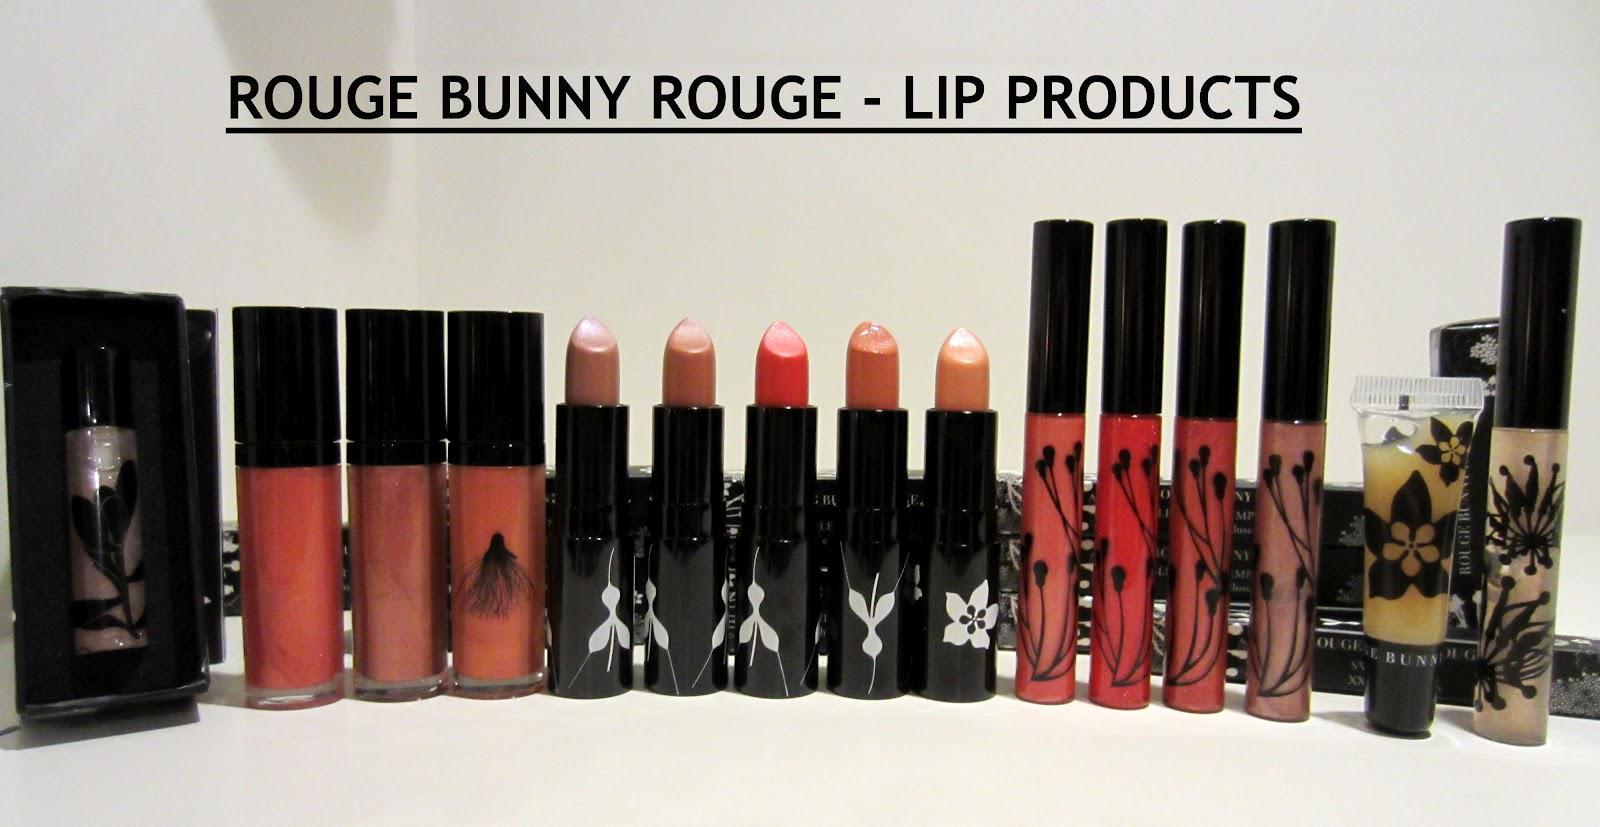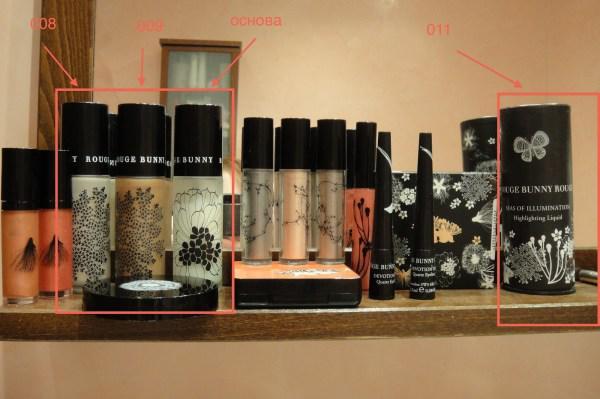The first image is the image on the left, the second image is the image on the right. For the images displayed, is the sentence "There are at least eight lip products in total." factually correct? Answer yes or no. Yes. The first image is the image on the left, the second image is the image on the right. Considering the images on both sides, is "there is no more then one lipstick visible in the right side pic" valid? Answer yes or no. No. The first image is the image on the left, the second image is the image on the right. Considering the images on both sides, is "In the left image, there is a single tube of makeup, and it has a clear body casing." valid? Answer yes or no. No. The first image is the image on the left, the second image is the image on the right. Examine the images to the left and right. Is the description "Lip applicants are displayed in a line of 11 or more." accurate? Answer yes or no. Yes. 